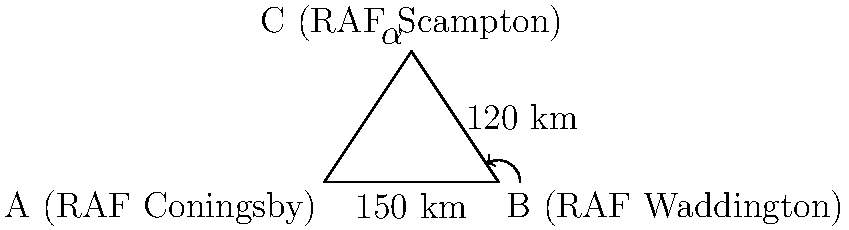As a Royal Air Force cadet, you're studying the distances between three RAF airfields in Lincolnshire: RAF Coningsby (A), RAF Waddington (B), and RAF Scampton (C). You know that the distance between Coningsby and Waddington is 150 km, and the distance between Waddington and Scampton is 120 km. The angle at Scampton between the other two airfields is $\alpha = 60°$. Using the law of cosines, calculate the distance between RAF Coningsby and RAF Scampton to the nearest kilometer. Let's solve this problem step by step using the law of cosines:

1) The law of cosines states: $c^2 = a^2 + b^2 - 2ab \cos(C)$

   Where:
   $c$ is the distance we're trying to find (between Coningsby and Scampton)
   $a = 150$ km (distance between Coningsby and Waddington)
   $b = 120$ km (distance between Waddington and Scampton)
   $C = \alpha = 60°$ (angle at Scampton)

2) Let's substitute these values into the formula:

   $c^2 = 150^2 + 120^2 - 2(150)(120) \cos(60°)$

3) Simplify:
   $c^2 = 22500 + 14400 - 36000 \cos(60°)$

4) $\cos(60°) = 0.5$, so:
   $c^2 = 22500 + 14400 - 36000(0.5)$
   $c^2 = 22500 + 14400 - 18000$
   $c^2 = 18900$

5) Take the square root of both sides:
   $c = \sqrt{18900} \approx 137.48$ km

6) Rounding to the nearest kilometer:
   $c \approx 137$ km

Therefore, the distance between RAF Coningsby and RAF Scampton is approximately 137 km.
Answer: 137 km 